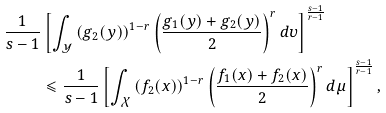<formula> <loc_0><loc_0><loc_500><loc_500>\frac { 1 } { s - 1 } & \left [ { \int _ { \mathcal { Y } } { \left ( { g _ { 2 } ( y ) } \right ) ^ { 1 - r } \left ( { \frac { g _ { 1 } ( y ) + g _ { 2 } ( y ) } { 2 } } \right ) ^ { r } d \upsilon } } \right ] ^ { \frac { s - 1 } { r - 1 } } \\ & \leqslant \frac { 1 } { s - 1 } \left [ { \int _ { \mathcal { X } } { \left ( { f _ { 2 } ( x ) } \right ) ^ { 1 - r } \left ( { \frac { f _ { 1 } ( x ) + f _ { 2 } ( x ) } { 2 } } \right ) ^ { r } d \mu } } \right ] ^ { \frac { s - 1 } { r - 1 } } ,</formula> 